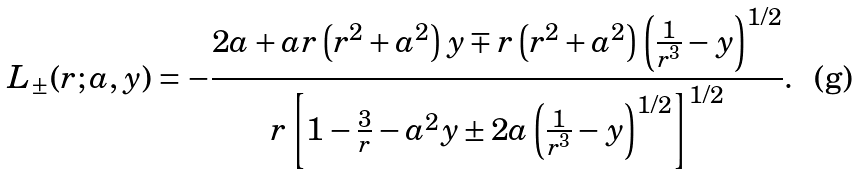Convert formula to latex. <formula><loc_0><loc_0><loc_500><loc_500>L _ { \pm } ( r ; a , y ) = - \frac { 2 a + a r \left ( r ^ { 2 } + a ^ { 2 } \right ) y \mp r \left ( r ^ { 2 } + a ^ { 2 } \right ) \left ( \frac { 1 } { r ^ { 3 } } - y \right ) ^ { 1 / 2 } } { r \left [ 1 - \frac { 3 } { r } - a ^ { 2 } y \pm 2 a \left ( \frac { 1 } { r ^ { 3 } } - y \right ) ^ { 1 / 2 } \right ] ^ { 1 / 2 } } .</formula> 